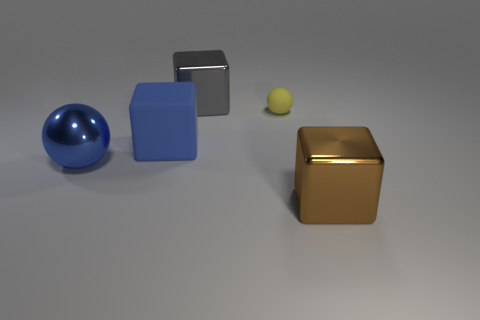There is a shiny object that is both in front of the small yellow thing and to the right of the big blue ball; what is its size? The shiny object in question appears to be medium-sized when compared to the surrounding items—the small yellow ball and the large blue ball. Its size is most accurately described as intermediate, making it neither particularly large nor small in the context of this scene. 